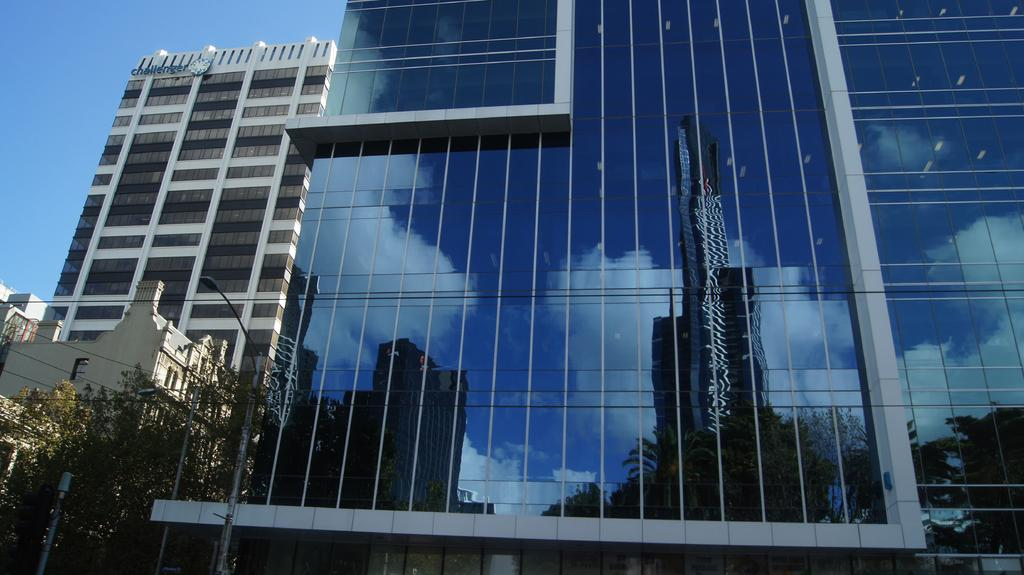What type of buildings are visible in the image? The buildings with glass are visible in the image. What can be seen at the bottom left of the image? There are trees and poles at the bottom left of the image. How does the glass on the buildings appear in the image? The building glass reflects other buildings and the sky. What type of land can be seen in the image? There is no specific type of land visible in the image; the image primarily features buildings and their reflections. 